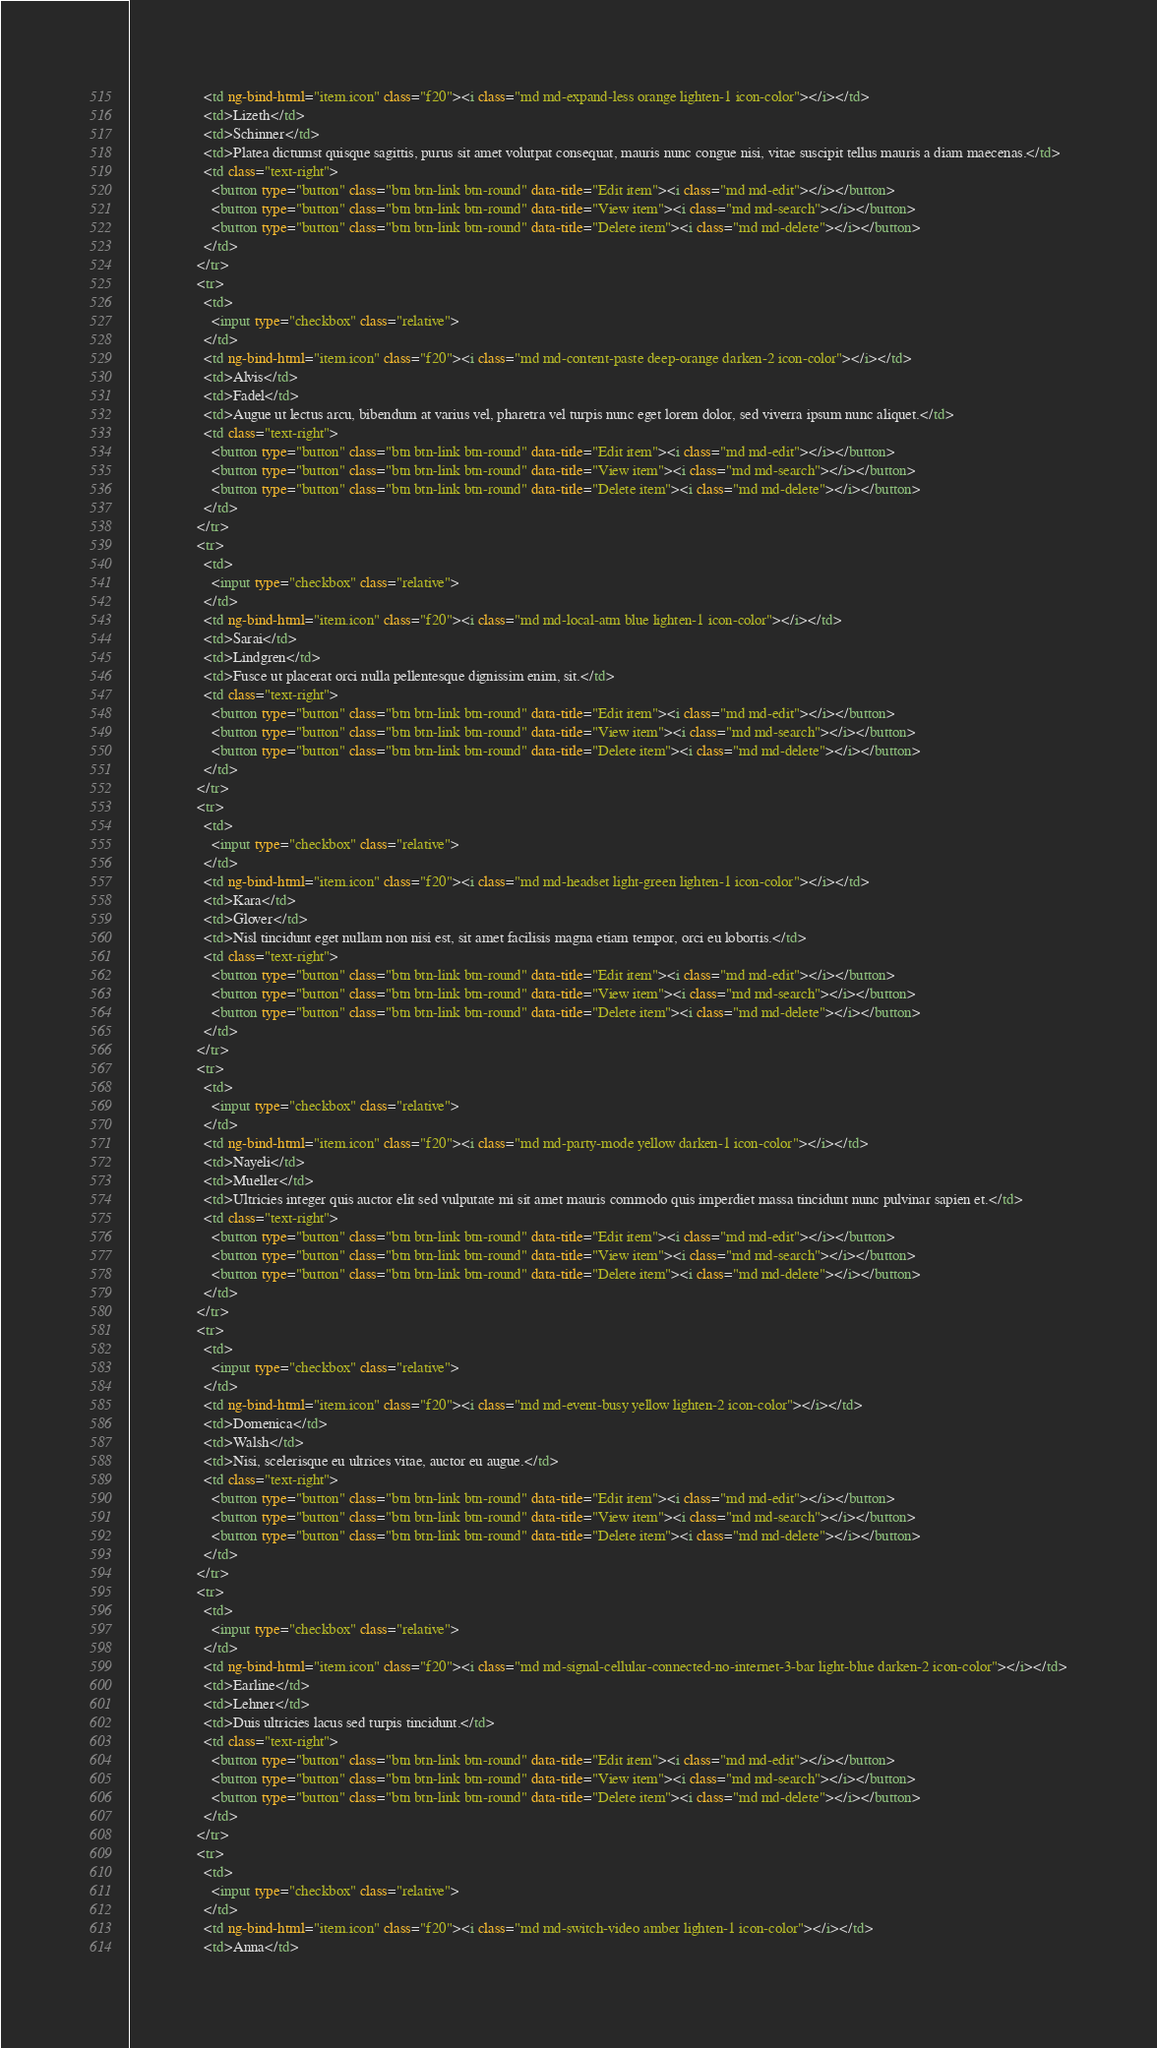Convert code to text. <code><loc_0><loc_0><loc_500><loc_500><_HTML_>                    <td ng-bind-html="item.icon" class="f20"><i class="md md-expand-less orange lighten-1 icon-color"></i></td>
                    <td>Lizeth</td>
                    <td>Schinner</td>
                    <td>Platea dictumst quisque sagittis, purus sit amet volutpat consequat, mauris nunc congue nisi, vitae suscipit tellus mauris a diam maecenas.</td>
                    <td class="text-right">
                      <button type="button" class="btn btn-link btn-round" data-title="Edit item"><i class="md md-edit"></i></button>
                      <button type="button" class="btn btn-link btn-round" data-title="View item"><i class="md md-search"></i></button>
                      <button type="button" class="btn btn-link btn-round" data-title="Delete item"><i class="md md-delete"></i></button>
                    </td>
                  </tr>
                  <tr>
                    <td>
                      <input type="checkbox" class="relative">
                    </td>
                    <td ng-bind-html="item.icon" class="f20"><i class="md md-content-paste deep-orange darken-2 icon-color"></i></td>
                    <td>Alvis</td>
                    <td>Fadel</td>
                    <td>Augue ut lectus arcu, bibendum at varius vel, pharetra vel turpis nunc eget lorem dolor, sed viverra ipsum nunc aliquet.</td>
                    <td class="text-right">
                      <button type="button" class="btn btn-link btn-round" data-title="Edit item"><i class="md md-edit"></i></button>
                      <button type="button" class="btn btn-link btn-round" data-title="View item"><i class="md md-search"></i></button>
                      <button type="button" class="btn btn-link btn-round" data-title="Delete item"><i class="md md-delete"></i></button>
                    </td>
                  </tr>
                  <tr>
                    <td>
                      <input type="checkbox" class="relative">
                    </td>
                    <td ng-bind-html="item.icon" class="f20"><i class="md md-local-atm blue lighten-1 icon-color"></i></td>
                    <td>Sarai</td>
                    <td>Lindgren</td>
                    <td>Fusce ut placerat orci nulla pellentesque dignissim enim, sit.</td>
                    <td class="text-right">
                      <button type="button" class="btn btn-link btn-round" data-title="Edit item"><i class="md md-edit"></i></button>
                      <button type="button" class="btn btn-link btn-round" data-title="View item"><i class="md md-search"></i></button>
                      <button type="button" class="btn btn-link btn-round" data-title="Delete item"><i class="md md-delete"></i></button>
                    </td>
                  </tr>
                  <tr>
                    <td>
                      <input type="checkbox" class="relative">
                    </td>
                    <td ng-bind-html="item.icon" class="f20"><i class="md md-headset light-green lighten-1 icon-color"></i></td>
                    <td>Kara</td>
                    <td>Glover</td>
                    <td>Nisl tincidunt eget nullam non nisi est, sit amet facilisis magna etiam tempor, orci eu lobortis.</td>
                    <td class="text-right">
                      <button type="button" class="btn btn-link btn-round" data-title="Edit item"><i class="md md-edit"></i></button>
                      <button type="button" class="btn btn-link btn-round" data-title="View item"><i class="md md-search"></i></button>
                      <button type="button" class="btn btn-link btn-round" data-title="Delete item"><i class="md md-delete"></i></button>
                    </td>
                  </tr>
                  <tr>
                    <td>
                      <input type="checkbox" class="relative">
                    </td>
                    <td ng-bind-html="item.icon" class="f20"><i class="md md-party-mode yellow darken-1 icon-color"></i></td>
                    <td>Nayeli</td>
                    <td>Mueller</td>
                    <td>Ultricies integer quis auctor elit sed vulputate mi sit amet mauris commodo quis imperdiet massa tincidunt nunc pulvinar sapien et.</td>
                    <td class="text-right">
                      <button type="button" class="btn btn-link btn-round" data-title="Edit item"><i class="md md-edit"></i></button>
                      <button type="button" class="btn btn-link btn-round" data-title="View item"><i class="md md-search"></i></button>
                      <button type="button" class="btn btn-link btn-round" data-title="Delete item"><i class="md md-delete"></i></button>
                    </td>
                  </tr>
                  <tr>
                    <td>
                      <input type="checkbox" class="relative">
                    </td>
                    <td ng-bind-html="item.icon" class="f20"><i class="md md-event-busy yellow lighten-2 icon-color"></i></td>
                    <td>Domenica</td>
                    <td>Walsh</td>
                    <td>Nisi, scelerisque eu ultrices vitae, auctor eu augue.</td>
                    <td class="text-right">
                      <button type="button" class="btn btn-link btn-round" data-title="Edit item"><i class="md md-edit"></i></button>
                      <button type="button" class="btn btn-link btn-round" data-title="View item"><i class="md md-search"></i></button>
                      <button type="button" class="btn btn-link btn-round" data-title="Delete item"><i class="md md-delete"></i></button>
                    </td>
                  </tr>
                  <tr>
                    <td>
                      <input type="checkbox" class="relative">
                    </td>
                    <td ng-bind-html="item.icon" class="f20"><i class="md md-signal-cellular-connected-no-internet-3-bar light-blue darken-2 icon-color"></i></td>
                    <td>Earline</td>
                    <td>Lehner</td>
                    <td>Duis ultricies lacus sed turpis tincidunt.</td>
                    <td class="text-right">
                      <button type="button" class="btn btn-link btn-round" data-title="Edit item"><i class="md md-edit"></i></button>
                      <button type="button" class="btn btn-link btn-round" data-title="View item"><i class="md md-search"></i></button>
                      <button type="button" class="btn btn-link btn-round" data-title="Delete item"><i class="md md-delete"></i></button>
                    </td>
                  </tr>
                  <tr>
                    <td>
                      <input type="checkbox" class="relative">
                    </td>
                    <td ng-bind-html="item.icon" class="f20"><i class="md md-switch-video amber lighten-1 icon-color"></i></td>
                    <td>Anna</td></code> 